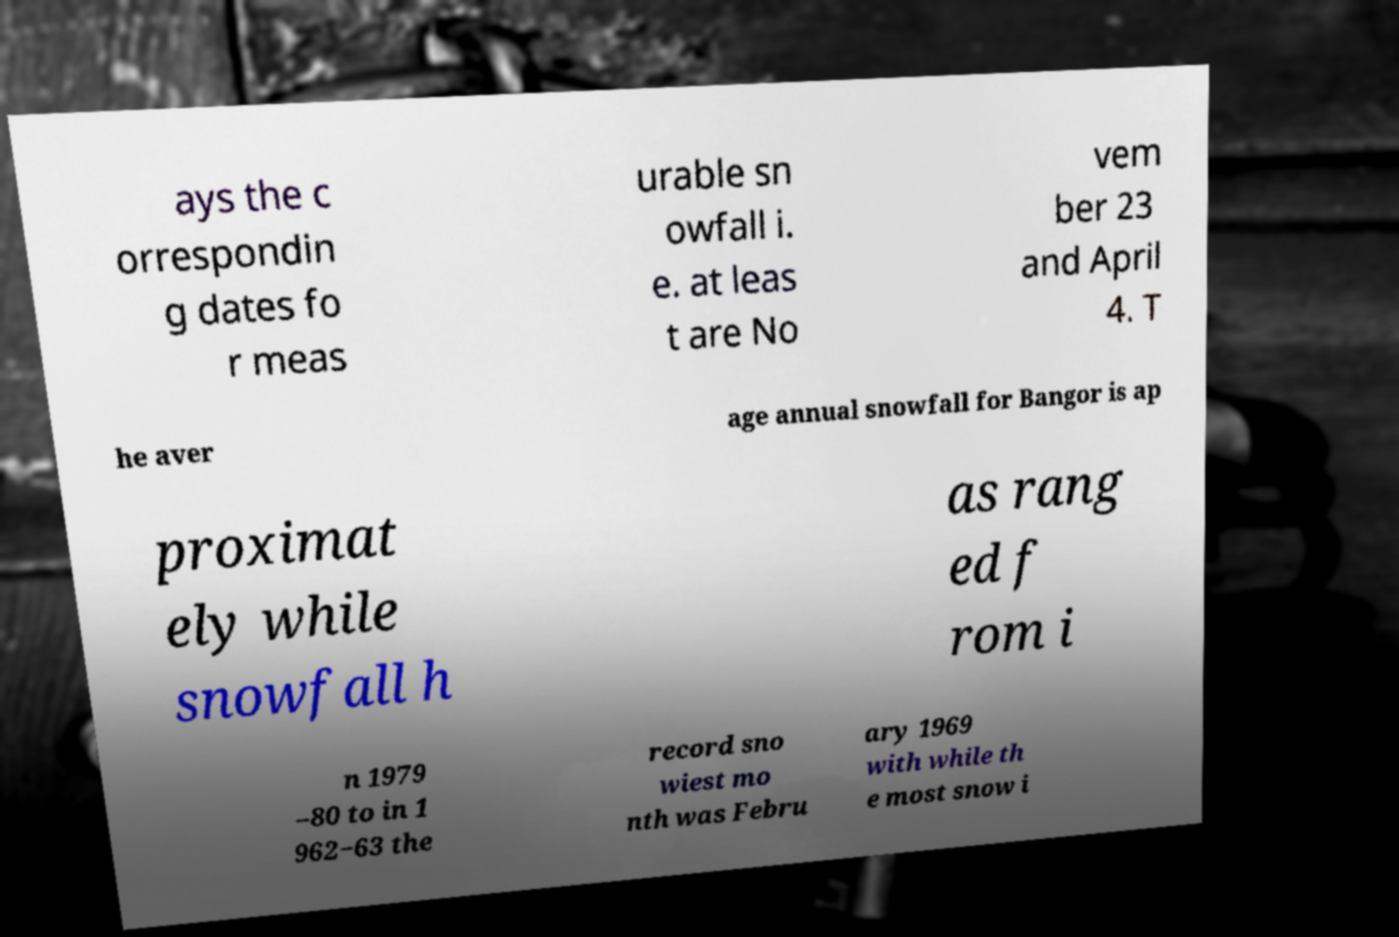There's text embedded in this image that I need extracted. Can you transcribe it verbatim? ays the c orrespondin g dates fo r meas urable sn owfall i. e. at leas t are No vem ber 23 and April 4. T he aver age annual snowfall for Bangor is ap proximat ely while snowfall h as rang ed f rom i n 1979 –80 to in 1 962−63 the record sno wiest mo nth was Febru ary 1969 with while th e most snow i 